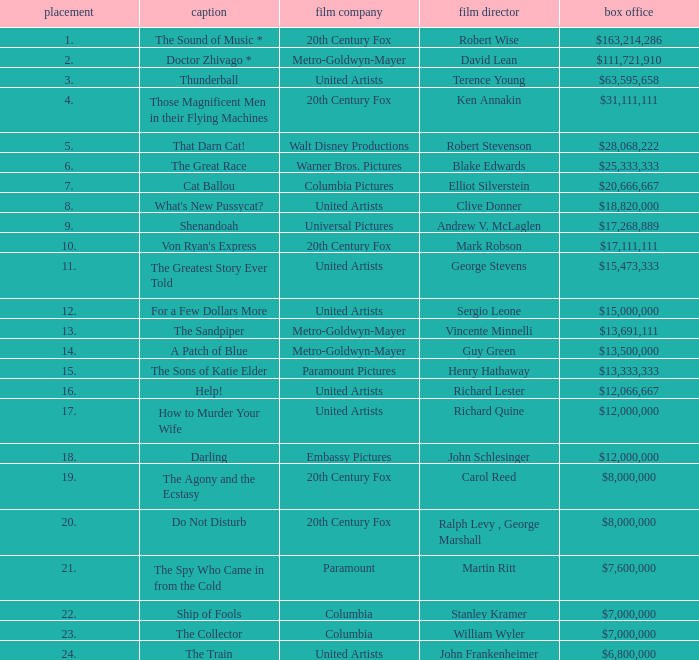What is the highest Rank, when Director is "Henry Hathaway"? 15.0. 